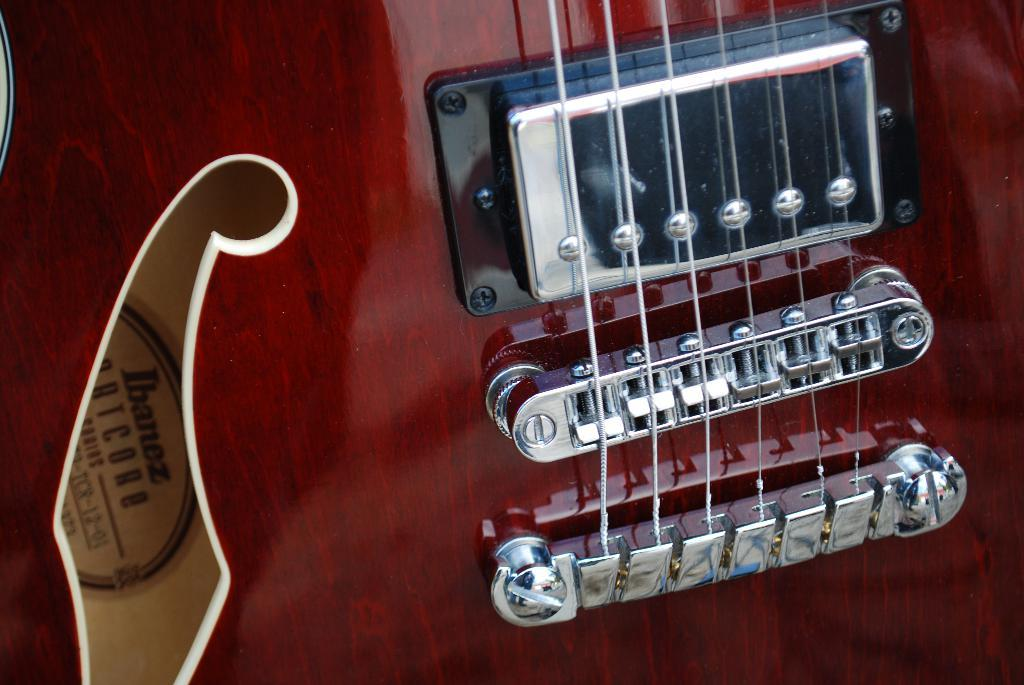What type of material can be seen in the image? Strings, metal objects, and a wooden object can be seen in the image. What is written on the wooden object? Something is written on the wooden object, but the specific text is not mentioned in the facts. What other materials might be present in the image? The facts do not mention any other materials, so we cannot definitively answer this question. How many kittens are playing on the wooden object in the image? There are no kittens present in the image. What type of animal can be seen claiming territory in the image? There is no animal present in the image, and therefore no territory is being claimed. 